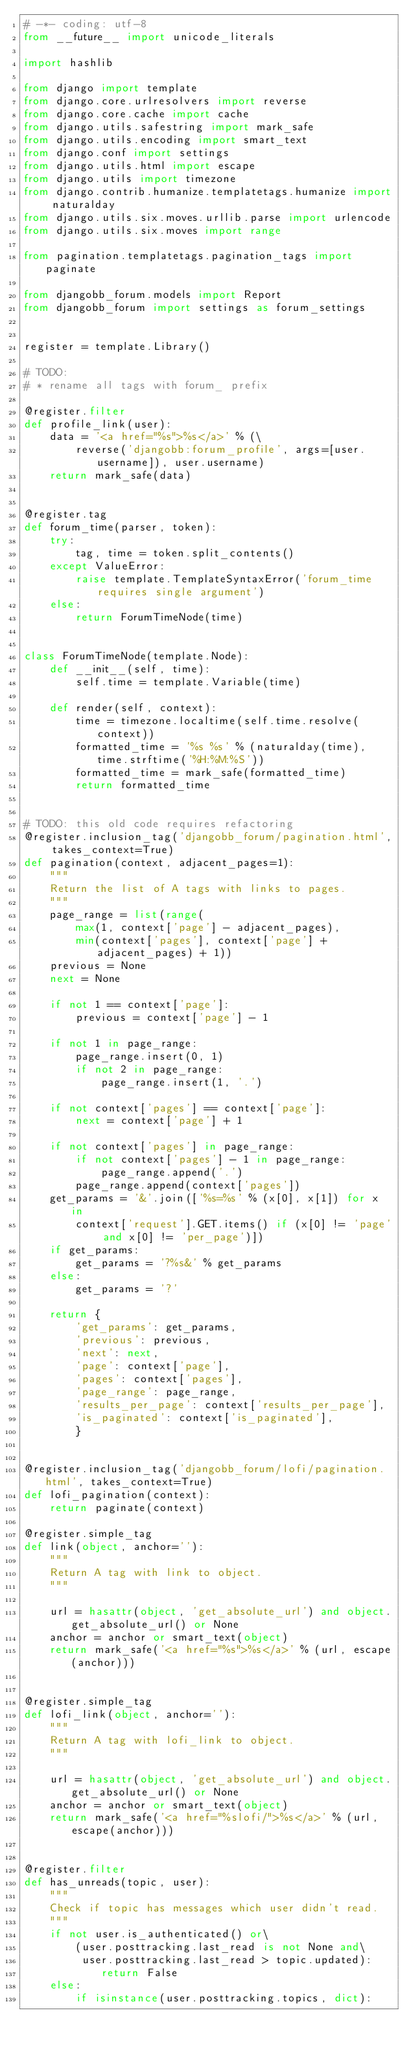<code> <loc_0><loc_0><loc_500><loc_500><_Python_># -*- coding: utf-8
from __future__ import unicode_literals

import hashlib

from django import template
from django.core.urlresolvers import reverse
from django.core.cache import cache
from django.utils.safestring import mark_safe
from django.utils.encoding import smart_text
from django.conf import settings
from django.utils.html import escape
from django.utils import timezone
from django.contrib.humanize.templatetags.humanize import naturalday
from django.utils.six.moves.urllib.parse import urlencode
from django.utils.six.moves import range

from pagination.templatetags.pagination_tags import paginate

from djangobb_forum.models import Report
from djangobb_forum import settings as forum_settings


register = template.Library()

# TODO:
# * rename all tags with forum_ prefix

@register.filter
def profile_link(user):
    data = '<a href="%s">%s</a>' % (\
        reverse('djangobb:forum_profile', args=[user.username]), user.username)
    return mark_safe(data)


@register.tag
def forum_time(parser, token):
    try:
        tag, time = token.split_contents()
    except ValueError:
        raise template.TemplateSyntaxError('forum_time requires single argument')
    else:
        return ForumTimeNode(time)


class ForumTimeNode(template.Node):
    def __init__(self, time):
        self.time = template.Variable(time)

    def render(self, context):
        time = timezone.localtime(self.time.resolve(context))
        formatted_time = '%s %s' % (naturalday(time), time.strftime('%H:%M:%S'))
        formatted_time = mark_safe(formatted_time)
        return formatted_time


# TODO: this old code requires refactoring
@register.inclusion_tag('djangobb_forum/pagination.html', takes_context=True)
def pagination(context, adjacent_pages=1):
    """
    Return the list of A tags with links to pages.
    """
    page_range = list(range(
        max(1, context['page'] - adjacent_pages),
        min(context['pages'], context['page'] + adjacent_pages) + 1))
    previous = None
    next = None

    if not 1 == context['page']:
        previous = context['page'] - 1

    if not 1 in page_range:
        page_range.insert(0, 1)
        if not 2 in page_range:
            page_range.insert(1, '.')

    if not context['pages'] == context['page']:
        next = context['page'] + 1

    if not context['pages'] in page_range:
        if not context['pages'] - 1 in page_range:
            page_range.append('.')
        page_range.append(context['pages'])
    get_params = '&'.join(['%s=%s' % (x[0], x[1]) for x in
        context['request'].GET.items() if (x[0] != 'page' and x[0] != 'per_page')])
    if get_params:
        get_params = '?%s&' % get_params
    else:
        get_params = '?'

    return {
        'get_params': get_params,
        'previous': previous,
        'next': next,
        'page': context['page'],
        'pages': context['pages'],
        'page_range': page_range,
        'results_per_page': context['results_per_page'],
        'is_paginated': context['is_paginated'],
        }


@register.inclusion_tag('djangobb_forum/lofi/pagination.html', takes_context=True)
def lofi_pagination(context):
    return paginate(context)

@register.simple_tag
def link(object, anchor=''):
    """
    Return A tag with link to object.
    """

    url = hasattr(object, 'get_absolute_url') and object.get_absolute_url() or None
    anchor = anchor or smart_text(object)
    return mark_safe('<a href="%s">%s</a>' % (url, escape(anchor)))


@register.simple_tag
def lofi_link(object, anchor=''):
    """
    Return A tag with lofi_link to object.
    """

    url = hasattr(object, 'get_absolute_url') and object.get_absolute_url() or None
    anchor = anchor or smart_text(object)
    return mark_safe('<a href="%slofi/">%s</a>' % (url, escape(anchor)))


@register.filter
def has_unreads(topic, user):
    """
    Check if topic has messages which user didn't read.
    """
    if not user.is_authenticated() or\
        (user.posttracking.last_read is not None and\
         user.posttracking.last_read > topic.updated):
            return False
    else:
        if isinstance(user.posttracking.topics, dict):</code> 